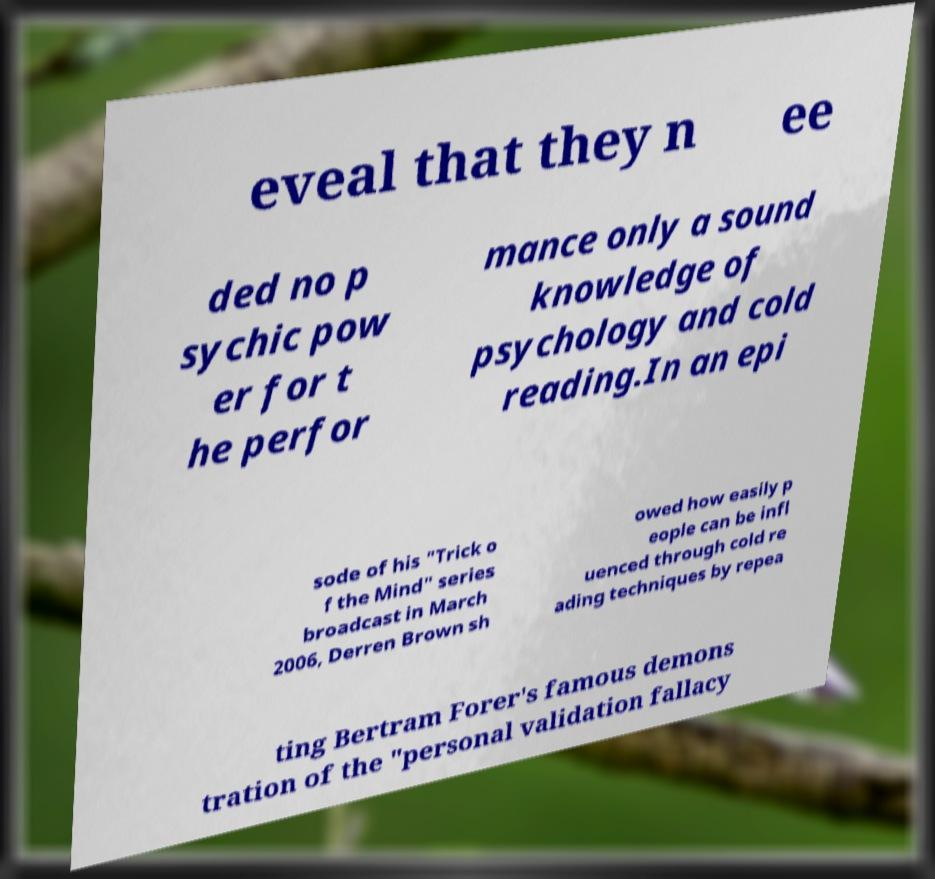What messages or text are displayed in this image? I need them in a readable, typed format. eveal that they n ee ded no p sychic pow er for t he perfor mance only a sound knowledge of psychology and cold reading.In an epi sode of his "Trick o f the Mind" series broadcast in March 2006, Derren Brown sh owed how easily p eople can be infl uenced through cold re ading techniques by repea ting Bertram Forer's famous demons tration of the "personal validation fallacy 